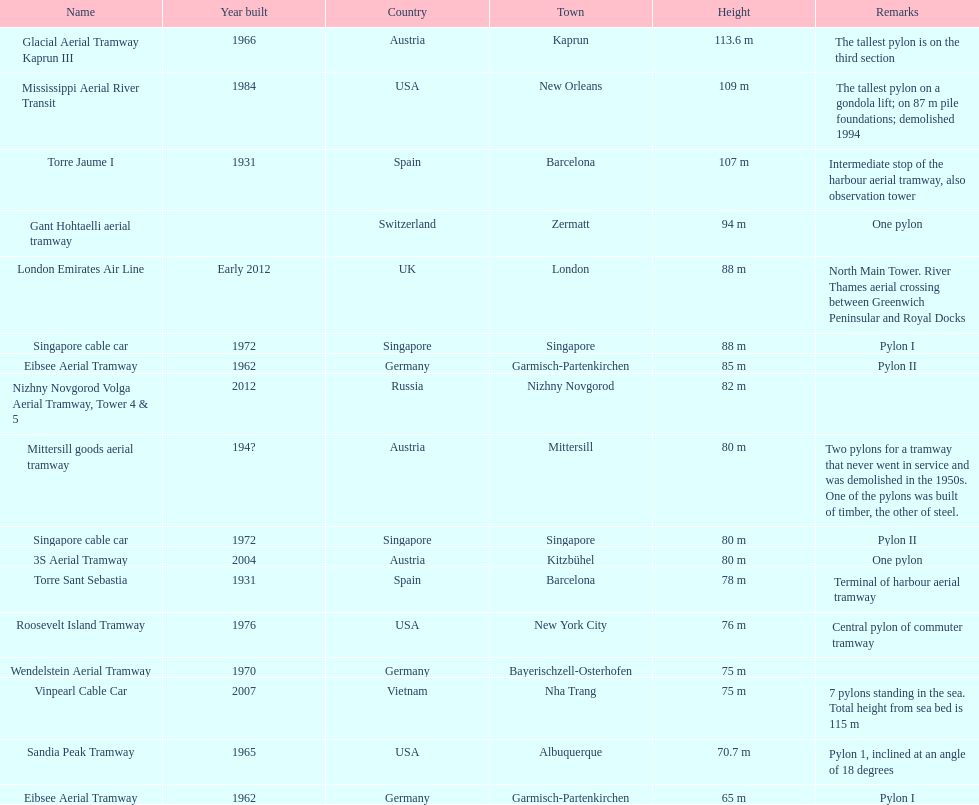Regarding which pylon are the most remarks made? Mittersill goods aerial tramway. 